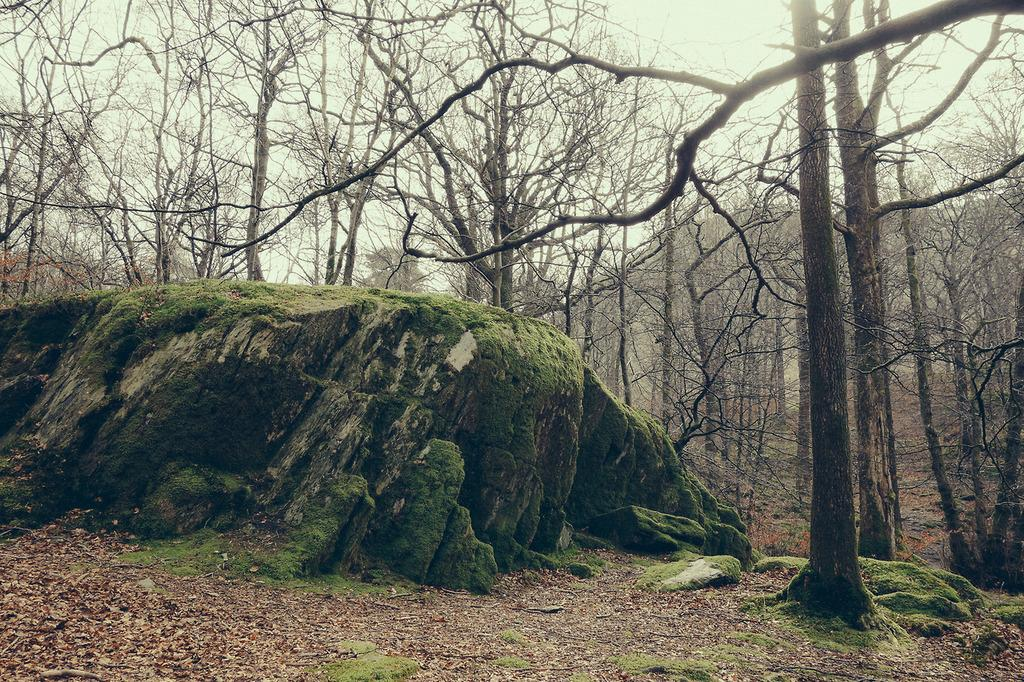What type of environment is depicted in the image? The image is taken in a forest. What is located in the front of the image? There is a rock in the front of the image. What can be seen at the bottom of the image? There is ground visible at the bottom of the image. What is visible in the background of the image? There are trees in the background of the image. What is the passenger discussing with the driver in the image? There is no passenger or driver present in the image, as it is taken in a forest with a rock, ground, and trees. 